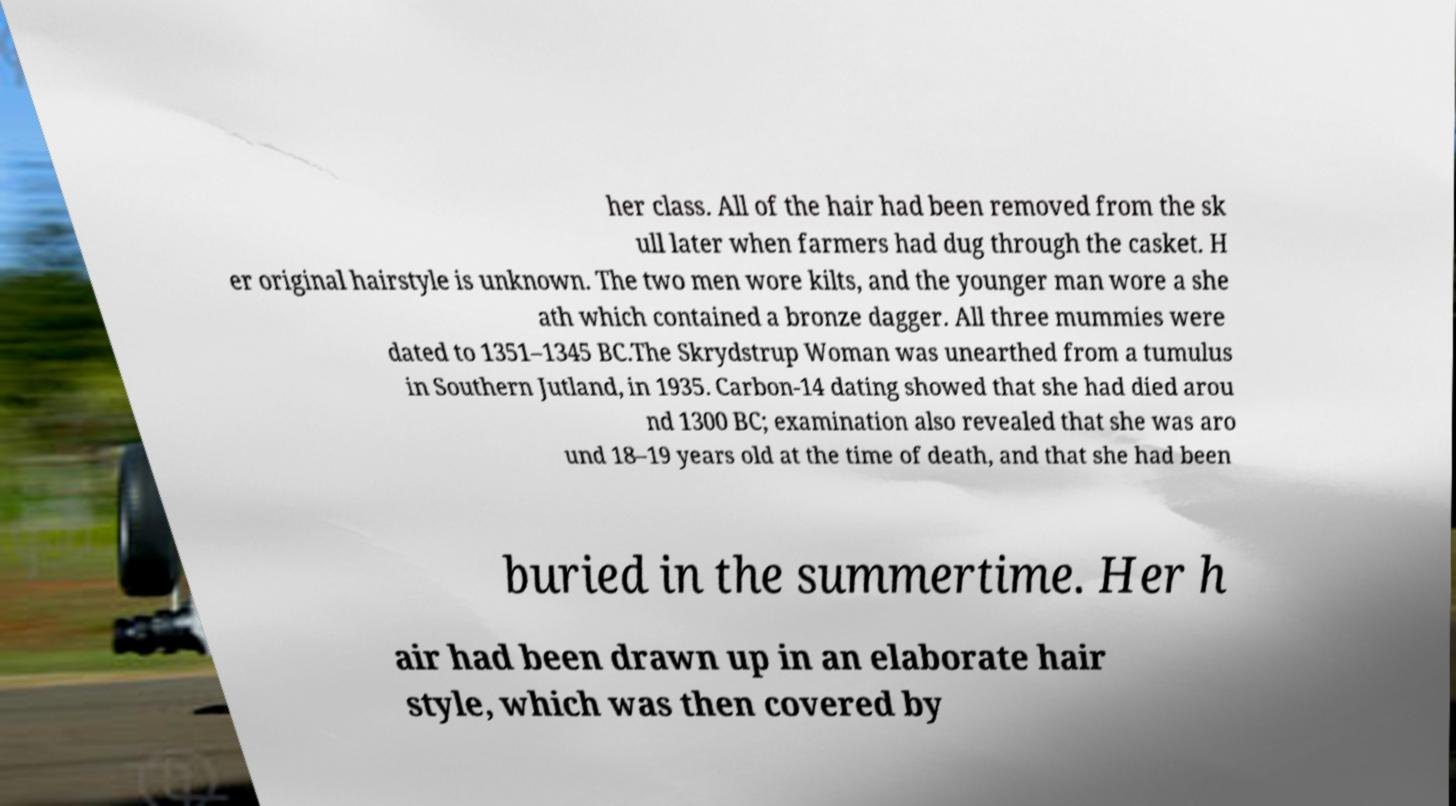There's text embedded in this image that I need extracted. Can you transcribe it verbatim? her class. All of the hair had been removed from the sk ull later when farmers had dug through the casket. H er original hairstyle is unknown. The two men wore kilts, and the younger man wore a she ath which contained a bronze dagger. All three mummies were dated to 1351–1345 BC.The Skrydstrup Woman was unearthed from a tumulus in Southern Jutland, in 1935. Carbon-14 dating showed that she had died arou nd 1300 BC; examination also revealed that she was aro und 18–19 years old at the time of death, and that she had been buried in the summertime. Her h air had been drawn up in an elaborate hair style, which was then covered by 